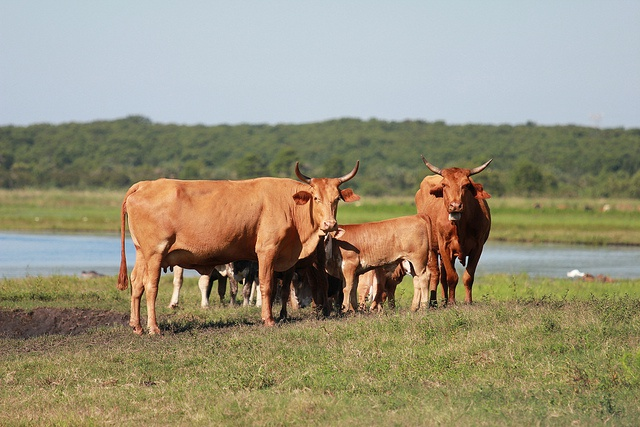Describe the objects in this image and their specific colors. I can see cow in lightblue, tan, maroon, black, and salmon tones, cow in lightblue, black, tan, brown, and maroon tones, cow in lightblue, tan, black, and salmon tones, cow in lightblue, black, gray, and tan tones, and cow in lightblue, black, tan, and beige tones in this image. 